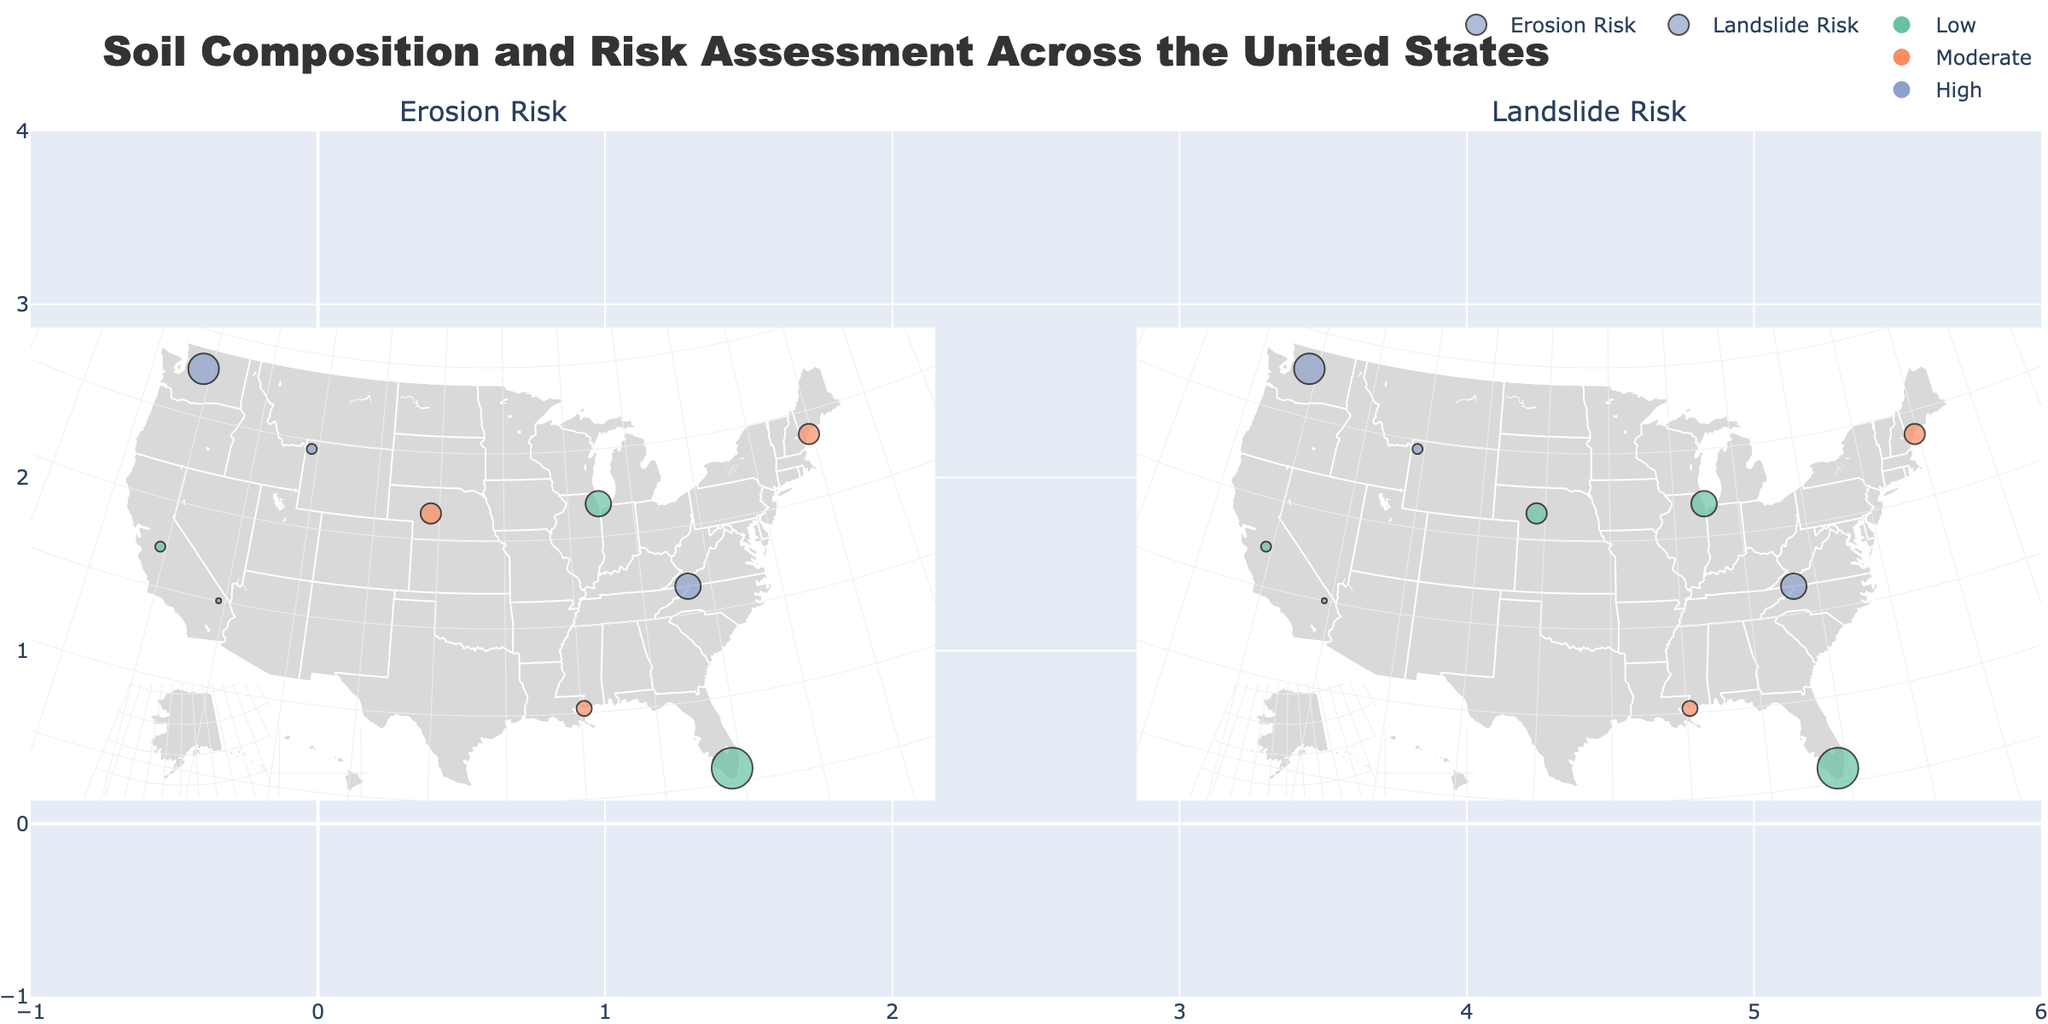How many regions are marked with 'High' erosion risk? Look at the subplot labeled 'Erosion Risk' and count the number of markers with the color indicating 'High' erosion risk (associated with a specific color). There are 4 such markers in the figure.
Answer: 4 Which region has the highest percentage of clay? By inspecting the hover text of all markers, identify the region with the highest clay percentage mentioned. The Florida Everglades has the highest clay percentage of 50%.
Answer: Florida Everglades What is the common organic matter percentage range among regions with a 'High' landslide risk? Identify all regions with markers indicating 'High' landslide risk in the 'Landslide Risk' subplot and note their organic matter percentages. The percentage range among these regions is between 2% and 6%.
Answer: 2% to 6% Which region in the plot has both 'Moderate' erosion and landslide risk? Look at the markers on both subplots and identify the region(s) that appear with 'Moderate' risk in both. The Gulf Coast and New England both have 'Moderate' erosion and landslide risks.
Answer: Gulf Coast, New England Which region has the lowest risk for both erosion and landslide? Identify the region(s) marked with 'Low' risk in both subplots. The Florida Everglades has the lowest risk for both erosion and landslide.
Answer: Florida Everglades Compare the clay percentage between the Appalachian Mountains and the Rocky Mountains. Which one is higher? Look at the hover information on markers for these two regions to compare their clay percentages. The Appalachian Mountains have 25% clay, while the Rocky Mountains have 15% clay. Therefore, the Appalachian Mountains have a higher clay percentage.
Answer: Appalachian Mountains What is the average sand percentage of regions with a 'Moderate' erosion risk? Collect the sand percentages of regions with 'Moderate' erosion risk (40% for Great Plains, 45% for Gulf Coast, and 40% for New England), then calculate the average: (40 + 45 + 40) / 3 = 41.67%.
Answer: 41.67% Which regions are prone to both erosion and landslides? Identify regions that have markers indicating 'High' risk in both subplots. The Rocky Mountains, Appalachian Mountains, and Pacific Northwest are prone to both erosion and landslides.
Answer: Rocky Mountains, Appalachian Mountains, Pacific Northwest What is the typical size of the markers, given their organic matter content? Marker size is determined by the organic matter percentage multiplied by 3. For example, a region with 8% organic matter has a marker size of 24 (8*3). Most regions follow this pattern.
Answer: 3 times the organic matter percentage 